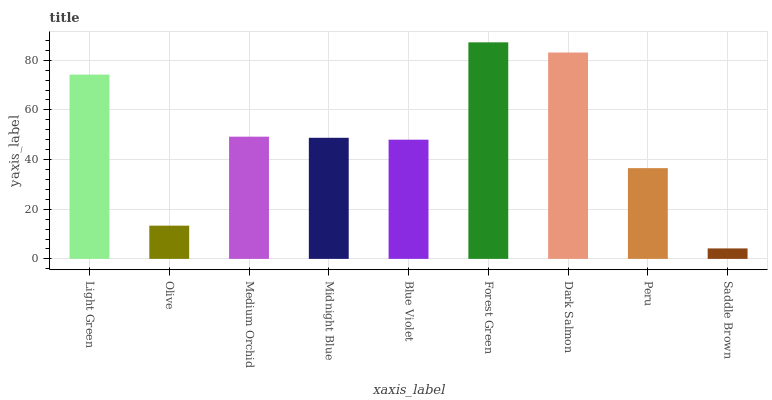Is Saddle Brown the minimum?
Answer yes or no. Yes. Is Forest Green the maximum?
Answer yes or no. Yes. Is Olive the minimum?
Answer yes or no. No. Is Olive the maximum?
Answer yes or no. No. Is Light Green greater than Olive?
Answer yes or no. Yes. Is Olive less than Light Green?
Answer yes or no. Yes. Is Olive greater than Light Green?
Answer yes or no. No. Is Light Green less than Olive?
Answer yes or no. No. Is Midnight Blue the high median?
Answer yes or no. Yes. Is Midnight Blue the low median?
Answer yes or no. Yes. Is Olive the high median?
Answer yes or no. No. Is Dark Salmon the low median?
Answer yes or no. No. 